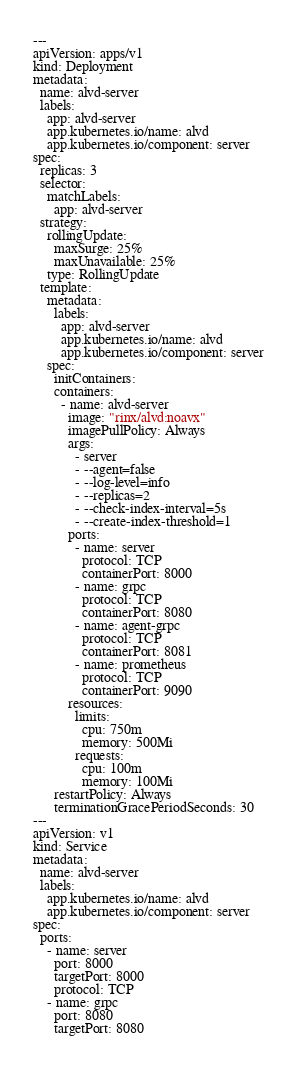<code> <loc_0><loc_0><loc_500><loc_500><_YAML_>---
apiVersion: apps/v1
kind: Deployment
metadata:
  name: alvd-server
  labels:
    app: alvd-server
    app.kubernetes.io/name: alvd
    app.kubernetes.io/component: server
spec:
  replicas: 3
  selector:
    matchLabels:
      app: alvd-server
  strategy:
    rollingUpdate:
      maxSurge: 25%
      maxUnavailable: 25%
    type: RollingUpdate
  template:
    metadata:
      labels:
        app: alvd-server
        app.kubernetes.io/name: alvd
        app.kubernetes.io/component: server
    spec:
      initContainers:
      containers:
        - name: alvd-server
          image: "rinx/alvd:noavx"
          imagePullPolicy: Always
          args:
            - server
            - --agent=false
            - --log-level=info
            - --replicas=2
            - --check-index-interval=5s
            - --create-index-threshold=1
          ports:
            - name: server
              protocol: TCP
              containerPort: 8000
            - name: grpc
              protocol: TCP
              containerPort: 8080
            - name: agent-grpc
              protocol: TCP
              containerPort: 8081
            - name: prometheus
              protocol: TCP
              containerPort: 9090
          resources:
            limits:
              cpu: 750m
              memory: 500Mi
            requests:
              cpu: 100m
              memory: 100Mi
      restartPolicy: Always
      terminationGracePeriodSeconds: 30
---
apiVersion: v1
kind: Service
metadata:
  name: alvd-server
  labels:
    app.kubernetes.io/name: alvd
    app.kubernetes.io/component: server
spec:
  ports:
    - name: server
      port: 8000
      targetPort: 8000
      protocol: TCP
    - name: grpc
      port: 8080
      targetPort: 8080</code> 